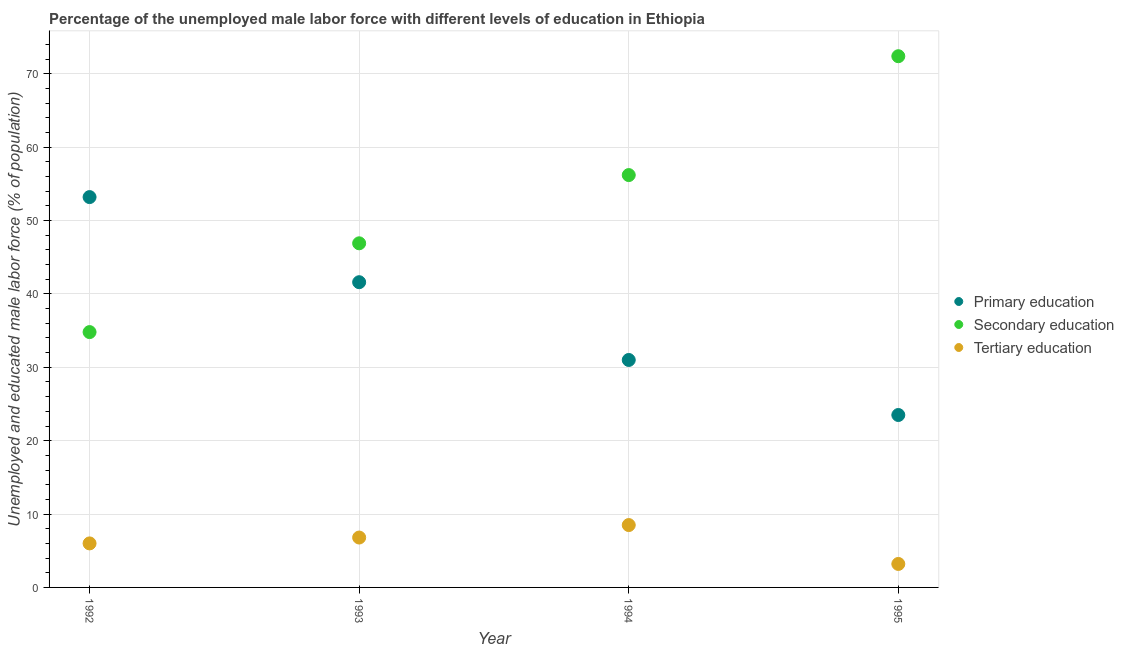How many different coloured dotlines are there?
Your response must be concise. 3. What is the percentage of male labor force who received primary education in 1994?
Ensure brevity in your answer.  31. Across all years, what is the maximum percentage of male labor force who received primary education?
Give a very brief answer. 53.2. Across all years, what is the minimum percentage of male labor force who received tertiary education?
Keep it short and to the point. 3.2. In which year was the percentage of male labor force who received secondary education maximum?
Ensure brevity in your answer.  1995. What is the total percentage of male labor force who received tertiary education in the graph?
Your answer should be very brief. 24.5. What is the difference between the percentage of male labor force who received secondary education in 1994 and that in 1995?
Your answer should be compact. -16.2. What is the difference between the percentage of male labor force who received tertiary education in 1994 and the percentage of male labor force who received secondary education in 1992?
Provide a short and direct response. -26.3. What is the average percentage of male labor force who received primary education per year?
Your answer should be very brief. 37.32. In the year 1994, what is the difference between the percentage of male labor force who received tertiary education and percentage of male labor force who received primary education?
Provide a short and direct response. -22.5. In how many years, is the percentage of male labor force who received tertiary education greater than 64 %?
Offer a terse response. 0. What is the ratio of the percentage of male labor force who received secondary education in 1992 to that in 1993?
Your answer should be compact. 0.74. Is the difference between the percentage of male labor force who received tertiary education in 1992 and 1995 greater than the difference between the percentage of male labor force who received secondary education in 1992 and 1995?
Provide a succinct answer. Yes. What is the difference between the highest and the second highest percentage of male labor force who received primary education?
Your answer should be compact. 11.6. What is the difference between the highest and the lowest percentage of male labor force who received secondary education?
Offer a terse response. 37.6. In how many years, is the percentage of male labor force who received primary education greater than the average percentage of male labor force who received primary education taken over all years?
Your answer should be compact. 2. Is the sum of the percentage of male labor force who received tertiary education in 1992 and 1995 greater than the maximum percentage of male labor force who received secondary education across all years?
Give a very brief answer. No. Is it the case that in every year, the sum of the percentage of male labor force who received primary education and percentage of male labor force who received secondary education is greater than the percentage of male labor force who received tertiary education?
Ensure brevity in your answer.  Yes. Is the percentage of male labor force who received secondary education strictly greater than the percentage of male labor force who received tertiary education over the years?
Provide a succinct answer. Yes. How many dotlines are there?
Your answer should be very brief. 3. What is the difference between two consecutive major ticks on the Y-axis?
Provide a short and direct response. 10. Are the values on the major ticks of Y-axis written in scientific E-notation?
Offer a terse response. No. Does the graph contain any zero values?
Make the answer very short. No. Does the graph contain grids?
Offer a very short reply. Yes. What is the title of the graph?
Offer a very short reply. Percentage of the unemployed male labor force with different levels of education in Ethiopia. What is the label or title of the Y-axis?
Offer a very short reply. Unemployed and educated male labor force (% of population). What is the Unemployed and educated male labor force (% of population) in Primary education in 1992?
Keep it short and to the point. 53.2. What is the Unemployed and educated male labor force (% of population) of Secondary education in 1992?
Offer a terse response. 34.8. What is the Unemployed and educated male labor force (% of population) in Primary education in 1993?
Provide a short and direct response. 41.6. What is the Unemployed and educated male labor force (% of population) in Secondary education in 1993?
Offer a very short reply. 46.9. What is the Unemployed and educated male labor force (% of population) in Tertiary education in 1993?
Ensure brevity in your answer.  6.8. What is the Unemployed and educated male labor force (% of population) of Primary education in 1994?
Your answer should be compact. 31. What is the Unemployed and educated male labor force (% of population) in Secondary education in 1994?
Keep it short and to the point. 56.2. What is the Unemployed and educated male labor force (% of population) in Primary education in 1995?
Offer a terse response. 23.5. What is the Unemployed and educated male labor force (% of population) in Secondary education in 1995?
Your response must be concise. 72.4. What is the Unemployed and educated male labor force (% of population) in Tertiary education in 1995?
Your response must be concise. 3.2. Across all years, what is the maximum Unemployed and educated male labor force (% of population) of Primary education?
Provide a succinct answer. 53.2. Across all years, what is the maximum Unemployed and educated male labor force (% of population) in Secondary education?
Give a very brief answer. 72.4. Across all years, what is the minimum Unemployed and educated male labor force (% of population) of Secondary education?
Offer a terse response. 34.8. Across all years, what is the minimum Unemployed and educated male labor force (% of population) in Tertiary education?
Give a very brief answer. 3.2. What is the total Unemployed and educated male labor force (% of population) of Primary education in the graph?
Ensure brevity in your answer.  149.3. What is the total Unemployed and educated male labor force (% of population) in Secondary education in the graph?
Offer a very short reply. 210.3. What is the total Unemployed and educated male labor force (% of population) of Tertiary education in the graph?
Give a very brief answer. 24.5. What is the difference between the Unemployed and educated male labor force (% of population) in Secondary education in 1992 and that in 1993?
Offer a very short reply. -12.1. What is the difference between the Unemployed and educated male labor force (% of population) of Secondary education in 1992 and that in 1994?
Offer a very short reply. -21.4. What is the difference between the Unemployed and educated male labor force (% of population) in Primary education in 1992 and that in 1995?
Offer a terse response. 29.7. What is the difference between the Unemployed and educated male labor force (% of population) of Secondary education in 1992 and that in 1995?
Give a very brief answer. -37.6. What is the difference between the Unemployed and educated male labor force (% of population) of Primary education in 1993 and that in 1994?
Your answer should be very brief. 10.6. What is the difference between the Unemployed and educated male labor force (% of population) in Secondary education in 1993 and that in 1994?
Offer a terse response. -9.3. What is the difference between the Unemployed and educated male labor force (% of population) of Tertiary education in 1993 and that in 1994?
Make the answer very short. -1.7. What is the difference between the Unemployed and educated male labor force (% of population) in Primary education in 1993 and that in 1995?
Offer a terse response. 18.1. What is the difference between the Unemployed and educated male labor force (% of population) in Secondary education in 1993 and that in 1995?
Your answer should be very brief. -25.5. What is the difference between the Unemployed and educated male labor force (% of population) of Tertiary education in 1993 and that in 1995?
Your response must be concise. 3.6. What is the difference between the Unemployed and educated male labor force (% of population) of Secondary education in 1994 and that in 1995?
Your response must be concise. -16.2. What is the difference between the Unemployed and educated male labor force (% of population) of Tertiary education in 1994 and that in 1995?
Make the answer very short. 5.3. What is the difference between the Unemployed and educated male labor force (% of population) of Primary education in 1992 and the Unemployed and educated male labor force (% of population) of Tertiary education in 1993?
Give a very brief answer. 46.4. What is the difference between the Unemployed and educated male labor force (% of population) in Secondary education in 1992 and the Unemployed and educated male labor force (% of population) in Tertiary education in 1993?
Your answer should be compact. 28. What is the difference between the Unemployed and educated male labor force (% of population) in Primary education in 1992 and the Unemployed and educated male labor force (% of population) in Tertiary education in 1994?
Your response must be concise. 44.7. What is the difference between the Unemployed and educated male labor force (% of population) in Secondary education in 1992 and the Unemployed and educated male labor force (% of population) in Tertiary education in 1994?
Offer a very short reply. 26.3. What is the difference between the Unemployed and educated male labor force (% of population) of Primary education in 1992 and the Unemployed and educated male labor force (% of population) of Secondary education in 1995?
Give a very brief answer. -19.2. What is the difference between the Unemployed and educated male labor force (% of population) of Secondary education in 1992 and the Unemployed and educated male labor force (% of population) of Tertiary education in 1995?
Give a very brief answer. 31.6. What is the difference between the Unemployed and educated male labor force (% of population) of Primary education in 1993 and the Unemployed and educated male labor force (% of population) of Secondary education in 1994?
Give a very brief answer. -14.6. What is the difference between the Unemployed and educated male labor force (% of population) of Primary education in 1993 and the Unemployed and educated male labor force (% of population) of Tertiary education in 1994?
Make the answer very short. 33.1. What is the difference between the Unemployed and educated male labor force (% of population) of Secondary education in 1993 and the Unemployed and educated male labor force (% of population) of Tertiary education in 1994?
Make the answer very short. 38.4. What is the difference between the Unemployed and educated male labor force (% of population) in Primary education in 1993 and the Unemployed and educated male labor force (% of population) in Secondary education in 1995?
Give a very brief answer. -30.8. What is the difference between the Unemployed and educated male labor force (% of population) of Primary education in 1993 and the Unemployed and educated male labor force (% of population) of Tertiary education in 1995?
Offer a very short reply. 38.4. What is the difference between the Unemployed and educated male labor force (% of population) in Secondary education in 1993 and the Unemployed and educated male labor force (% of population) in Tertiary education in 1995?
Ensure brevity in your answer.  43.7. What is the difference between the Unemployed and educated male labor force (% of population) in Primary education in 1994 and the Unemployed and educated male labor force (% of population) in Secondary education in 1995?
Offer a very short reply. -41.4. What is the difference between the Unemployed and educated male labor force (% of population) of Primary education in 1994 and the Unemployed and educated male labor force (% of population) of Tertiary education in 1995?
Ensure brevity in your answer.  27.8. What is the average Unemployed and educated male labor force (% of population) of Primary education per year?
Ensure brevity in your answer.  37.33. What is the average Unemployed and educated male labor force (% of population) in Secondary education per year?
Provide a short and direct response. 52.58. What is the average Unemployed and educated male labor force (% of population) of Tertiary education per year?
Your answer should be very brief. 6.12. In the year 1992, what is the difference between the Unemployed and educated male labor force (% of population) in Primary education and Unemployed and educated male labor force (% of population) in Secondary education?
Ensure brevity in your answer.  18.4. In the year 1992, what is the difference between the Unemployed and educated male labor force (% of population) of Primary education and Unemployed and educated male labor force (% of population) of Tertiary education?
Provide a short and direct response. 47.2. In the year 1992, what is the difference between the Unemployed and educated male labor force (% of population) in Secondary education and Unemployed and educated male labor force (% of population) in Tertiary education?
Give a very brief answer. 28.8. In the year 1993, what is the difference between the Unemployed and educated male labor force (% of population) of Primary education and Unemployed and educated male labor force (% of population) of Tertiary education?
Keep it short and to the point. 34.8. In the year 1993, what is the difference between the Unemployed and educated male labor force (% of population) in Secondary education and Unemployed and educated male labor force (% of population) in Tertiary education?
Provide a short and direct response. 40.1. In the year 1994, what is the difference between the Unemployed and educated male labor force (% of population) of Primary education and Unemployed and educated male labor force (% of population) of Secondary education?
Make the answer very short. -25.2. In the year 1994, what is the difference between the Unemployed and educated male labor force (% of population) of Secondary education and Unemployed and educated male labor force (% of population) of Tertiary education?
Your answer should be compact. 47.7. In the year 1995, what is the difference between the Unemployed and educated male labor force (% of population) of Primary education and Unemployed and educated male labor force (% of population) of Secondary education?
Keep it short and to the point. -48.9. In the year 1995, what is the difference between the Unemployed and educated male labor force (% of population) of Primary education and Unemployed and educated male labor force (% of population) of Tertiary education?
Ensure brevity in your answer.  20.3. In the year 1995, what is the difference between the Unemployed and educated male labor force (% of population) in Secondary education and Unemployed and educated male labor force (% of population) in Tertiary education?
Provide a short and direct response. 69.2. What is the ratio of the Unemployed and educated male labor force (% of population) of Primary education in 1992 to that in 1993?
Offer a very short reply. 1.28. What is the ratio of the Unemployed and educated male labor force (% of population) of Secondary education in 1992 to that in 1993?
Your answer should be compact. 0.74. What is the ratio of the Unemployed and educated male labor force (% of population) in Tertiary education in 1992 to that in 1993?
Offer a very short reply. 0.88. What is the ratio of the Unemployed and educated male labor force (% of population) of Primary education in 1992 to that in 1994?
Your answer should be compact. 1.72. What is the ratio of the Unemployed and educated male labor force (% of population) in Secondary education in 1992 to that in 1994?
Keep it short and to the point. 0.62. What is the ratio of the Unemployed and educated male labor force (% of population) in Tertiary education in 1992 to that in 1994?
Your answer should be very brief. 0.71. What is the ratio of the Unemployed and educated male labor force (% of population) in Primary education in 1992 to that in 1995?
Offer a very short reply. 2.26. What is the ratio of the Unemployed and educated male labor force (% of population) of Secondary education in 1992 to that in 1995?
Your answer should be compact. 0.48. What is the ratio of the Unemployed and educated male labor force (% of population) in Tertiary education in 1992 to that in 1995?
Your response must be concise. 1.88. What is the ratio of the Unemployed and educated male labor force (% of population) in Primary education in 1993 to that in 1994?
Provide a short and direct response. 1.34. What is the ratio of the Unemployed and educated male labor force (% of population) of Secondary education in 1993 to that in 1994?
Offer a very short reply. 0.83. What is the ratio of the Unemployed and educated male labor force (% of population) of Primary education in 1993 to that in 1995?
Offer a very short reply. 1.77. What is the ratio of the Unemployed and educated male labor force (% of population) in Secondary education in 1993 to that in 1995?
Offer a very short reply. 0.65. What is the ratio of the Unemployed and educated male labor force (% of population) of Tertiary education in 1993 to that in 1995?
Provide a succinct answer. 2.12. What is the ratio of the Unemployed and educated male labor force (% of population) of Primary education in 1994 to that in 1995?
Make the answer very short. 1.32. What is the ratio of the Unemployed and educated male labor force (% of population) in Secondary education in 1994 to that in 1995?
Provide a succinct answer. 0.78. What is the ratio of the Unemployed and educated male labor force (% of population) of Tertiary education in 1994 to that in 1995?
Offer a terse response. 2.66. What is the difference between the highest and the second highest Unemployed and educated male labor force (% of population) of Primary education?
Keep it short and to the point. 11.6. What is the difference between the highest and the second highest Unemployed and educated male labor force (% of population) of Tertiary education?
Provide a succinct answer. 1.7. What is the difference between the highest and the lowest Unemployed and educated male labor force (% of population) in Primary education?
Ensure brevity in your answer.  29.7. What is the difference between the highest and the lowest Unemployed and educated male labor force (% of population) of Secondary education?
Make the answer very short. 37.6. What is the difference between the highest and the lowest Unemployed and educated male labor force (% of population) in Tertiary education?
Provide a short and direct response. 5.3. 